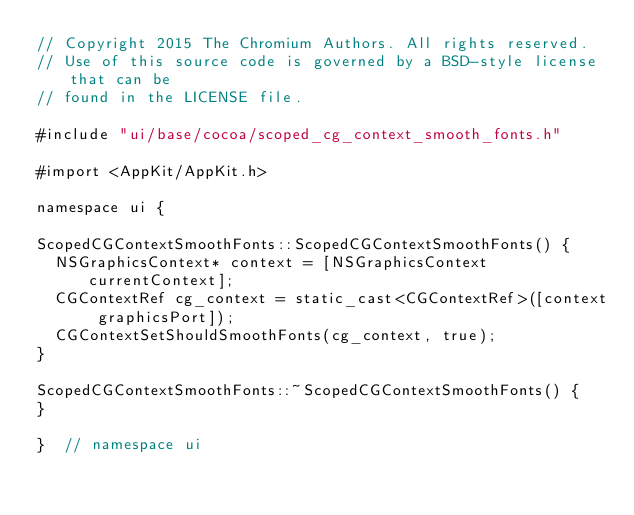<code> <loc_0><loc_0><loc_500><loc_500><_ObjectiveC_>// Copyright 2015 The Chromium Authors. All rights reserved.
// Use of this source code is governed by a BSD-style license that can be
// found in the LICENSE file.

#include "ui/base/cocoa/scoped_cg_context_smooth_fonts.h"

#import <AppKit/AppKit.h>

namespace ui {

ScopedCGContextSmoothFonts::ScopedCGContextSmoothFonts() {
  NSGraphicsContext* context = [NSGraphicsContext currentContext];
  CGContextRef cg_context = static_cast<CGContextRef>([context graphicsPort]);
  CGContextSetShouldSmoothFonts(cg_context, true);
}

ScopedCGContextSmoothFonts::~ScopedCGContextSmoothFonts() {
}

}  // namespace ui
</code> 